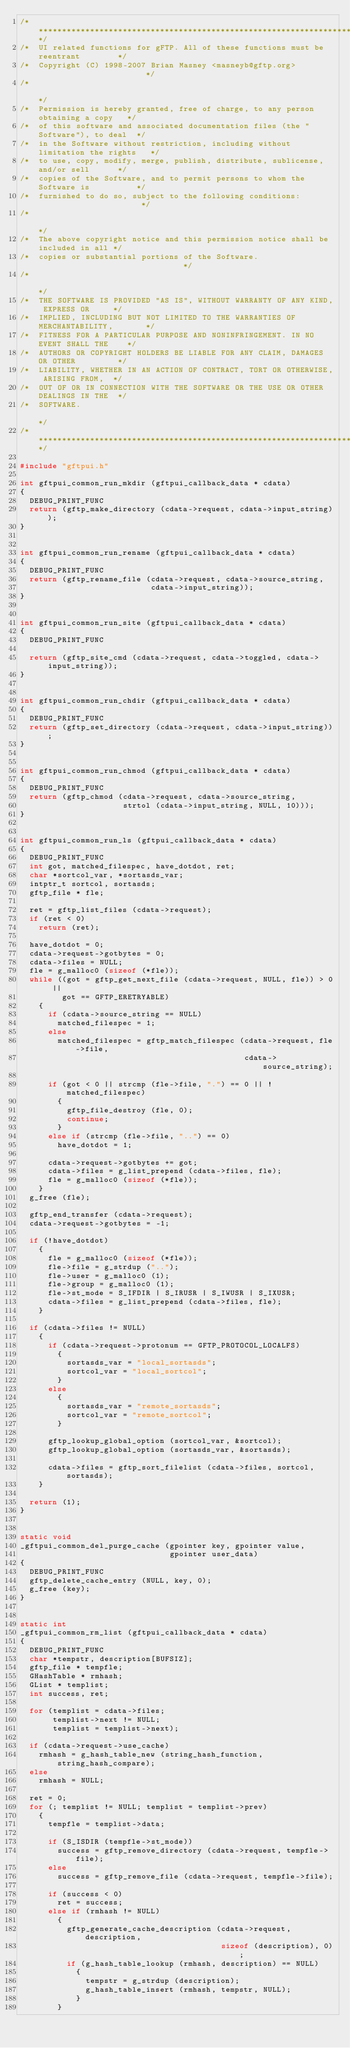<code> <loc_0><loc_0><loc_500><loc_500><_C_>/***********************************************************************************/
/*  UI related functions for gFTP. All of these functions must be reentrant        */
/*  Copyright (C) 1998-2007 Brian Masney <masneyb@gftp.org>                        */
/*                                                                                 */
/*  Permission is hereby granted, free of charge, to any person obtaining a copy   */
/*  of this software and associated documentation files (the "Software"), to deal  */
/*  in the Software without restriction, including without limitation the rights   */
/*  to use, copy, modify, merge, publish, distribute, sublicense, and/or sell      */
/*  copies of the Software, and to permit persons to whom the Software is          */
/*  furnished to do so, subject to the following conditions:                       */
/*                                                                                 */
/*  The above copyright notice and this permission notice shall be included in all */
/*  copies or substantial portions of the Software.                                */
/*                                                                                 */
/*  THE SOFTWARE IS PROVIDED "AS IS", WITHOUT WARRANTY OF ANY KIND, EXPRESS OR     */
/*  IMPLIED, INCLUDING BUT NOT LIMITED TO THE WARRANTIES OF MERCHANTABILITY,       */
/*  FITNESS FOR A PARTICULAR PURPOSE AND NONINFRINGEMENT. IN NO EVENT SHALL THE    */
/*  AUTHORS OR COPYRIGHT HOLDERS BE LIABLE FOR ANY CLAIM, DAMAGES OR OTHER         */
/*  LIABILITY, WHETHER IN AN ACTION OF CONTRACT, TORT OR OTHERWISE, ARISING FROM,  */
/*  OUT OF OR IN CONNECTION WITH THE SOFTWARE OR THE USE OR OTHER DEALINGS IN THE  */
/*  SOFTWARE.                                                                      */
/***********************************************************************************/

#include "gftpui.h"

int gftpui_common_run_mkdir (gftpui_callback_data * cdata)
{
  DEBUG_PRINT_FUNC
  return (gftp_make_directory (cdata->request, cdata->input_string));
}


int gftpui_common_run_rename (gftpui_callback_data * cdata)
{
  DEBUG_PRINT_FUNC
  return (gftp_rename_file (cdata->request, cdata->source_string,
                            cdata->input_string));
}


int gftpui_common_run_site (gftpui_callback_data * cdata)
{
  DEBUG_PRINT_FUNC

  return (gftp_site_cmd (cdata->request, cdata->toggled, cdata->input_string));
}


int gftpui_common_run_chdir (gftpui_callback_data * cdata)
{
  DEBUG_PRINT_FUNC
  return (gftp_set_directory (cdata->request, cdata->input_string));
}


int gftpui_common_run_chmod (gftpui_callback_data * cdata)
{
  DEBUG_PRINT_FUNC
  return (gftp_chmod (cdata->request, cdata->source_string,
                      strtol (cdata->input_string, NULL, 10)));
}


int gftpui_common_run_ls (gftpui_callback_data * cdata)
{
  DEBUG_PRINT_FUNC
  int got, matched_filespec, have_dotdot, ret;
  char *sortcol_var, *sortasds_var;
  intptr_t sortcol, sortasds;
  gftp_file * fle;

  ret = gftp_list_files (cdata->request);
  if (ret < 0)
    return (ret);

  have_dotdot = 0;
  cdata->request->gotbytes = 0;
  cdata->files = NULL;
  fle = g_malloc0 (sizeof (*fle));
  while ((got = gftp_get_next_file (cdata->request, NULL, fle)) > 0 ||
         got == GFTP_ERETRYABLE)
    {
      if (cdata->source_string == NULL)
        matched_filespec = 1;
      else
        matched_filespec = gftp_match_filespec (cdata->request, fle->file,
                                                cdata->source_string);

      if (got < 0 || strcmp (fle->file, ".") == 0 || !matched_filespec)
        {
          gftp_file_destroy (fle, 0);
          continue;
        }
      else if (strcmp (fle->file, "..") == 0)
        have_dotdot = 1;

      cdata->request->gotbytes += got;
      cdata->files = g_list_prepend (cdata->files, fle);
      fle = g_malloc0 (sizeof (*fle));
    }
  g_free (fle);

  gftp_end_transfer (cdata->request);
  cdata->request->gotbytes = -1;

  if (!have_dotdot)
    {
      fle = g_malloc0 (sizeof (*fle));
      fle->file = g_strdup ("..");
      fle->user = g_malloc0 (1);
      fle->group = g_malloc0 (1);
      fle->st_mode = S_IFDIR | S_IRUSR | S_IWUSR | S_IXUSR;
      cdata->files = g_list_prepend (cdata->files, fle);
    }

  if (cdata->files != NULL)
    {
      if (cdata->request->protonum == GFTP_PROTOCOL_LOCALFS)
        {
          sortasds_var = "local_sortasds";
          sortcol_var = "local_sortcol";
        }
      else
        {
          sortasds_var = "remote_sortasds";
          sortcol_var = "remote_sortcol";
        }

      gftp_lookup_global_option (sortcol_var, &sortcol);
      gftp_lookup_global_option (sortasds_var, &sortasds);
    
      cdata->files = gftp_sort_filelist (cdata->files, sortcol, sortasds);
    }

  return (1);
}


static void
_gftpui_common_del_purge_cache (gpointer key, gpointer value,
                                gpointer user_data)
{
  DEBUG_PRINT_FUNC
  gftp_delete_cache_entry (NULL, key, 0);
  g_free (key);
}


static int
_gftpui_common_rm_list (gftpui_callback_data * cdata)
{
  DEBUG_PRINT_FUNC
  char *tempstr, description[BUFSIZ];
  gftp_file * tempfle;
  GHashTable * rmhash;
  GList * templist;
  int success, ret;

  for (templist = cdata->files;
       templist->next != NULL;
       templist = templist->next); 

  if (cdata->request->use_cache)
    rmhash = g_hash_table_new (string_hash_function, string_hash_compare);
  else
    rmhash = NULL;

  ret = 0;
  for (; templist != NULL; templist = templist->prev)
    { 
      tempfle = templist->data;

      if (S_ISDIR (tempfle->st_mode))
        success = gftp_remove_directory (cdata->request, tempfle->file);
      else
        success = gftp_remove_file (cdata->request, tempfle->file);

      if (success < 0)
        ret = success;
      else if (rmhash != NULL)
        {
          gftp_generate_cache_description (cdata->request, description,
                                           sizeof (description), 0);
          if (g_hash_table_lookup (rmhash, description) == NULL)
            {
              tempstr = g_strdup (description);
              g_hash_table_insert (rmhash, tempstr, NULL);
            }
        }
</code> 